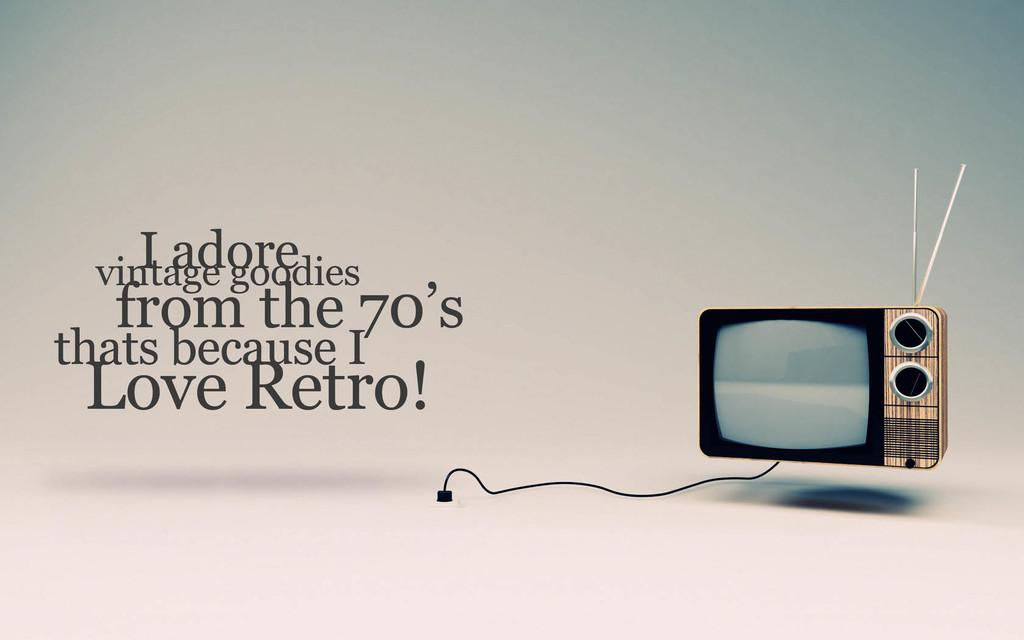<image>
Provide a brief description of the given image. An old television is shown next to text about love for retro items. 